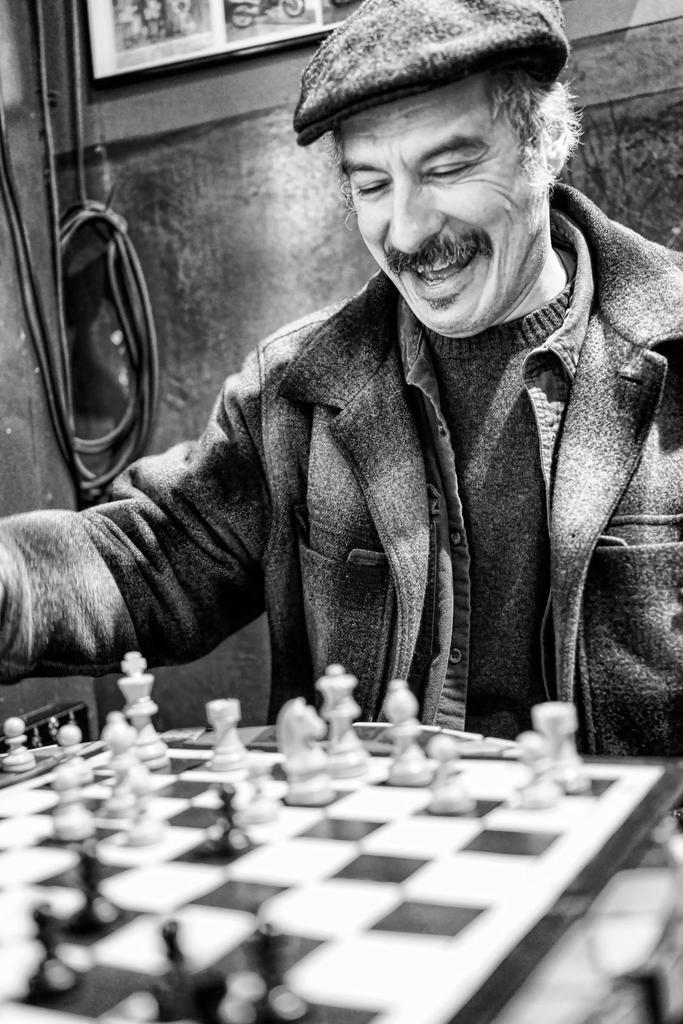Describe this image in one or two sentences. In this image in the foreground there is one person who is sitting and smiling and it seems that he is playing chess, in front of him there is one chess board and in the background there is a wall and some wires and photo frames. 